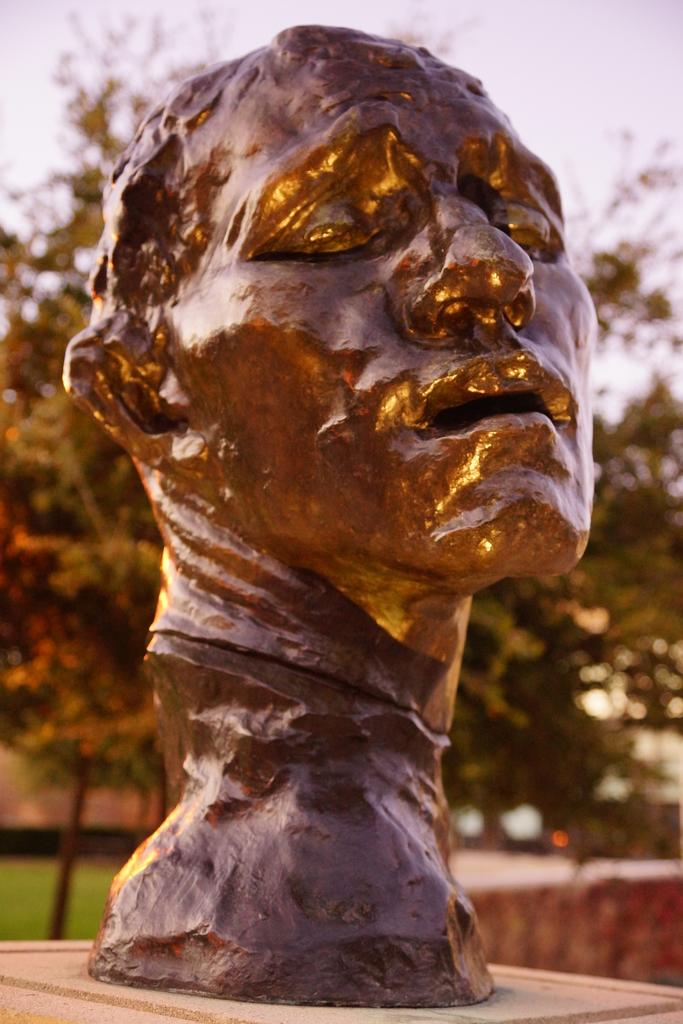What is the main subject in the center of the image? There is a statue in the center of the image. What can be seen in the background of the image? There are trees in the background of the image. What type of duck is sitting on the statue in the image? There is no duck present in the image. 